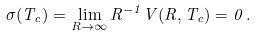Convert formula to latex. <formula><loc_0><loc_0><loc_500><loc_500>\sigma ( T _ { c } ) = \lim _ { R \to \infty } R ^ { - 1 } V ( R , T _ { c } ) = 0 \, { . }</formula> 